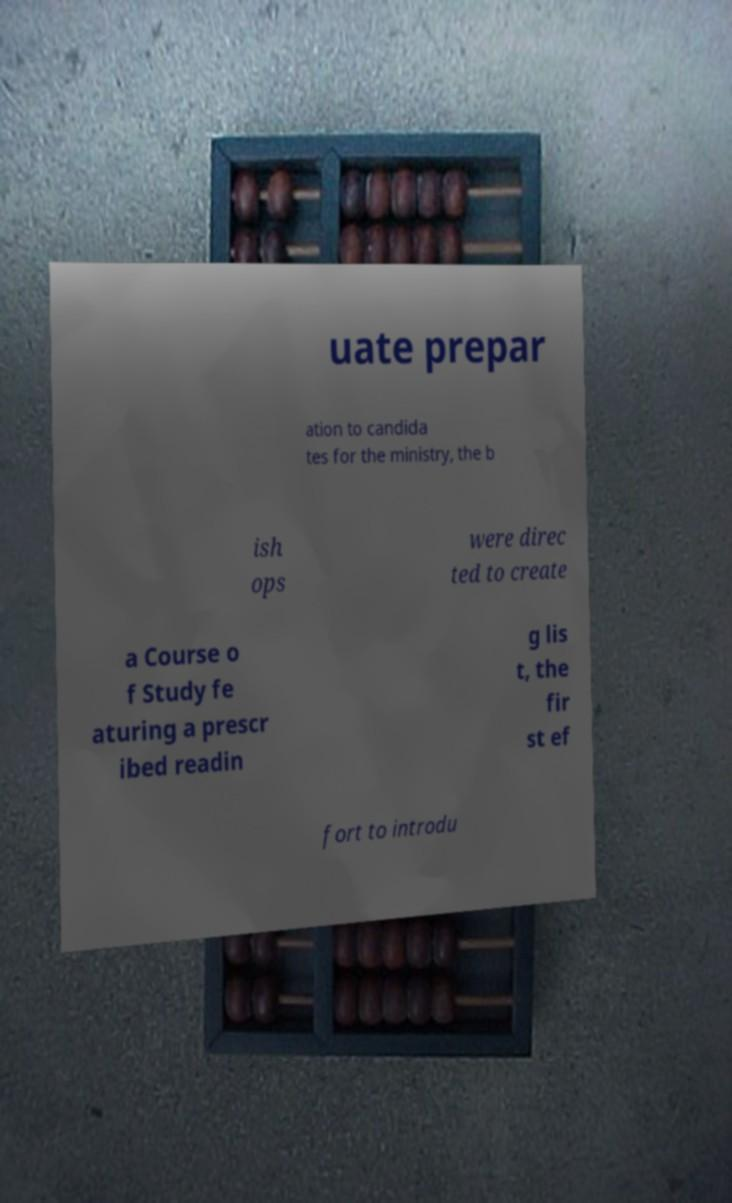Please identify and transcribe the text found in this image. uate prepar ation to candida tes for the ministry, the b ish ops were direc ted to create a Course o f Study fe aturing a prescr ibed readin g lis t, the fir st ef fort to introdu 